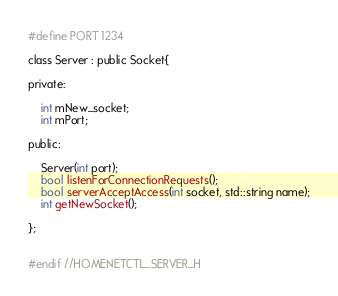Convert code to text. <code><loc_0><loc_0><loc_500><loc_500><_C_>#define PORT 1234

class Server : public Socket{

private:

    int mNew_socket;
    int mPort;

public:

    Server(int port);
    bool listenForConnectionRequests();
    bool serverAcceptAccess(int socket, std::string name);
    int getNewSocket();

};


#endif //HOMENETCTL_SERVER_H
</code> 